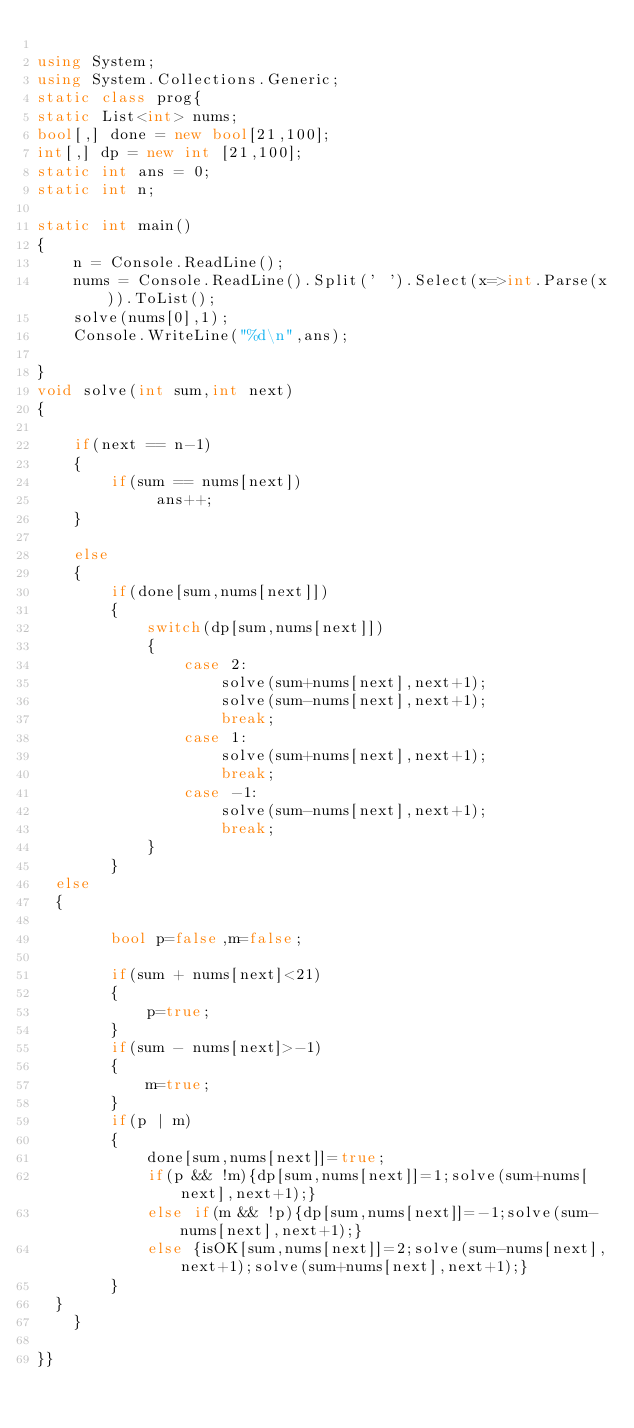<code> <loc_0><loc_0><loc_500><loc_500><_C#_>
using System;
using System.Collections.Generic;
static class prog{
static List<int> nums;
bool[,] done = new bool[21,100];
int[,] dp = new int [21,100];
static int ans = 0;
static int n;

static int main()
{
    n = Console.ReadLine();
    nums = Console.ReadLine().Split(' ').Select(x=>int.Parse(x)).ToList();
    solve(nums[0],1);
    Console.WriteLine("%d\n",ans);

}
void solve(int sum,int next)
{

    if(next == n-1)
    {
        if(sum == nums[next])
             ans++;
    }

    else
    {
        if(done[sum,nums[next]])
        {
            switch(dp[sum,nums[next]])
            {
                case 2:
                    solve(sum+nums[next],next+1);
                    solve(sum-nums[next],next+1);
                    break;
                case 1:
                    solve(sum+nums[next],next+1);
                    break;
                case -1:
                    solve(sum-nums[next],next+1);
                    break;
            }
        }
	else
	{

        bool p=false,m=false;
     
        if(sum + nums[next]<21)
        {
            p=true;
        }
        if(sum - nums[next]>-1)
        {
            m=true;
        }
        if(p | m)
        {
            done[sum,nums[next]]=true;
            if(p && !m){dp[sum,nums[next]]=1;solve(sum+nums[next],next+1);}
            else if(m && !p){dp[sum,nums[next]]=-1;solve(sum-nums[next],next+1);}
            else {isOK[sum,nums[next]]=2;solve(sum-nums[next],next+1);solve(sum+nums[next],next+1);}
        }
	}
    }

}}</code> 